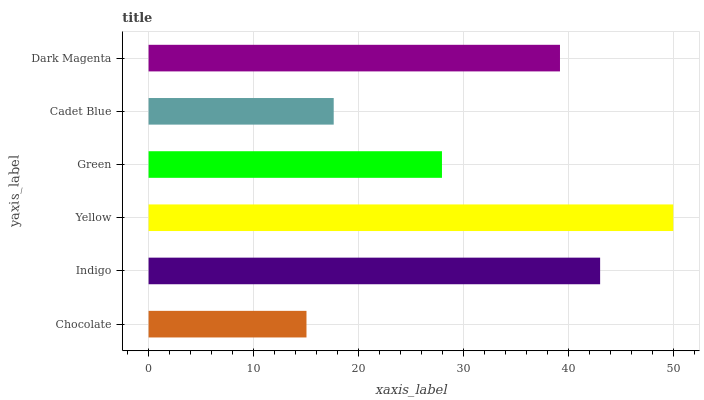Is Chocolate the minimum?
Answer yes or no. Yes. Is Yellow the maximum?
Answer yes or no. Yes. Is Indigo the minimum?
Answer yes or no. No. Is Indigo the maximum?
Answer yes or no. No. Is Indigo greater than Chocolate?
Answer yes or no. Yes. Is Chocolate less than Indigo?
Answer yes or no. Yes. Is Chocolate greater than Indigo?
Answer yes or no. No. Is Indigo less than Chocolate?
Answer yes or no. No. Is Dark Magenta the high median?
Answer yes or no. Yes. Is Green the low median?
Answer yes or no. Yes. Is Chocolate the high median?
Answer yes or no. No. Is Cadet Blue the low median?
Answer yes or no. No. 